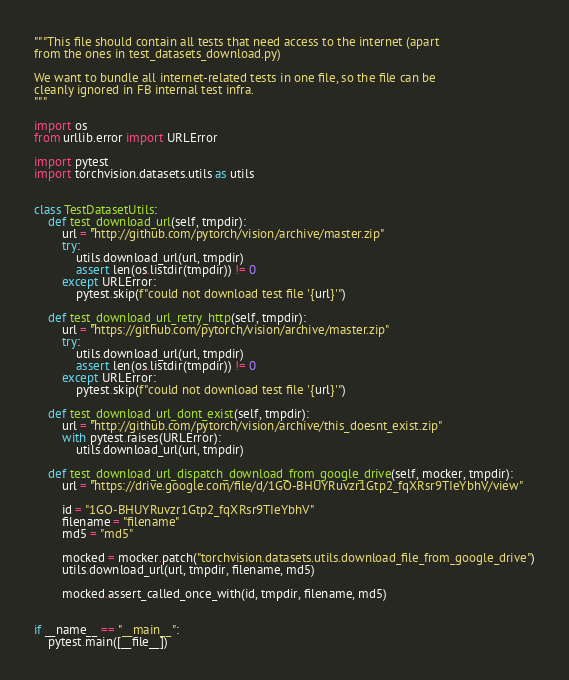Convert code to text. <code><loc_0><loc_0><loc_500><loc_500><_Python_>"""This file should contain all tests that need access to the internet (apart
from the ones in test_datasets_download.py)

We want to bundle all internet-related tests in one file, so the file can be
cleanly ignored in FB internal test infra.
"""

import os
from urllib.error import URLError

import pytest
import torchvision.datasets.utils as utils


class TestDatasetUtils:
    def test_download_url(self, tmpdir):
        url = "http://github.com/pytorch/vision/archive/master.zip"
        try:
            utils.download_url(url, tmpdir)
            assert len(os.listdir(tmpdir)) != 0
        except URLError:
            pytest.skip(f"could not download test file '{url}'")

    def test_download_url_retry_http(self, tmpdir):
        url = "https://github.com/pytorch/vision/archive/master.zip"
        try:
            utils.download_url(url, tmpdir)
            assert len(os.listdir(tmpdir)) != 0
        except URLError:
            pytest.skip(f"could not download test file '{url}'")

    def test_download_url_dont_exist(self, tmpdir):
        url = "http://github.com/pytorch/vision/archive/this_doesnt_exist.zip"
        with pytest.raises(URLError):
            utils.download_url(url, tmpdir)

    def test_download_url_dispatch_download_from_google_drive(self, mocker, tmpdir):
        url = "https://drive.google.com/file/d/1GO-BHUYRuvzr1Gtp2_fqXRsr9TIeYbhV/view"

        id = "1GO-BHUYRuvzr1Gtp2_fqXRsr9TIeYbhV"
        filename = "filename"
        md5 = "md5"

        mocked = mocker.patch("torchvision.datasets.utils.download_file_from_google_drive")
        utils.download_url(url, tmpdir, filename, md5)

        mocked.assert_called_once_with(id, tmpdir, filename, md5)


if __name__ == "__main__":
    pytest.main([__file__])
</code> 